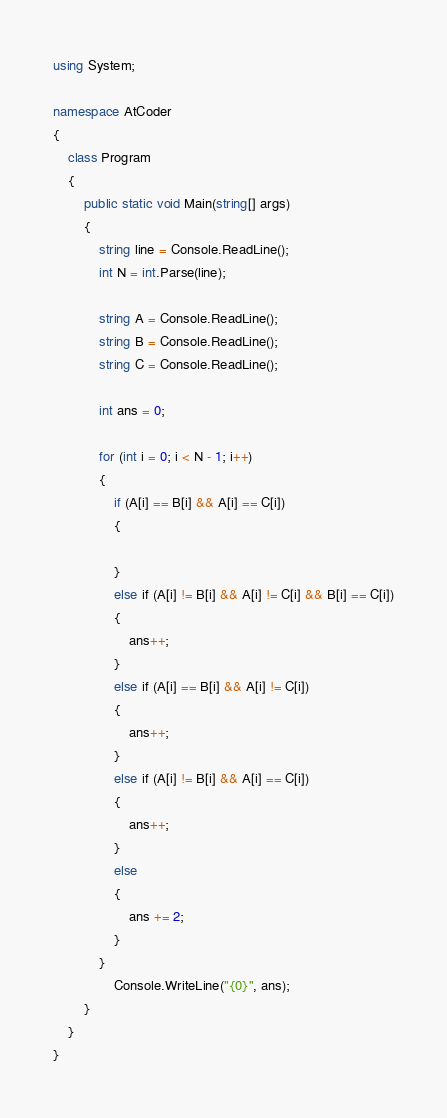Convert code to text. <code><loc_0><loc_0><loc_500><loc_500><_C#_>using System;

namespace AtCoder
{
    class Program
    {
        public static void Main(string[] args)
        {
            string line = Console.ReadLine();
            int N = int.Parse(line);

            string A = Console.ReadLine();
            string B = Console.ReadLine();
            string C = Console.ReadLine();

            int ans = 0;

            for (int i = 0; i < N - 1; i++)
            {
                if (A[i] == B[i] && A[i] == C[i])
                {

                }
                else if (A[i] != B[i] && A[i] != C[i] && B[i] == C[i])
                {
                    ans++;
                }
                else if (A[i] == B[i] && A[i] != C[i])
                {
                    ans++;
                }
                else if (A[i] != B[i] && A[i] == C[i])
                {
                    ans++;
                }
                else
                {
                    ans += 2;
                }
            }
                Console.WriteLine("{0}", ans);
        }
    }
}
</code> 